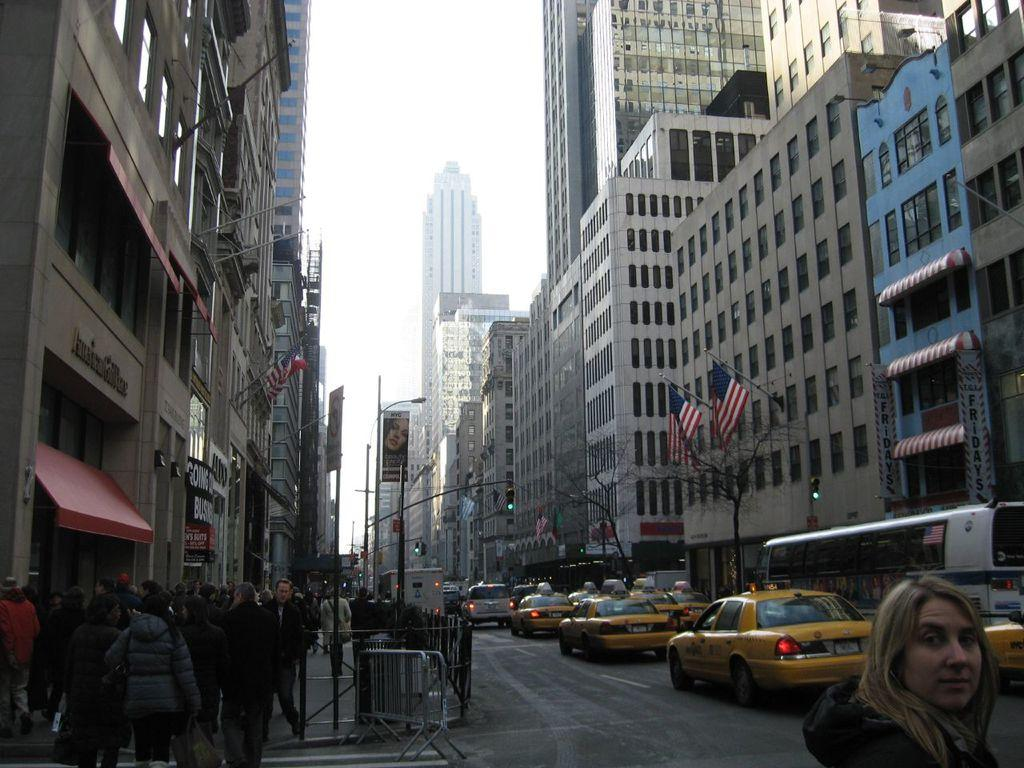Provide a one-sentence caption for the provided image. People walking on a street in front of an American Girl Place building. 